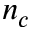Convert formula to latex. <formula><loc_0><loc_0><loc_500><loc_500>n _ { c }</formula> 